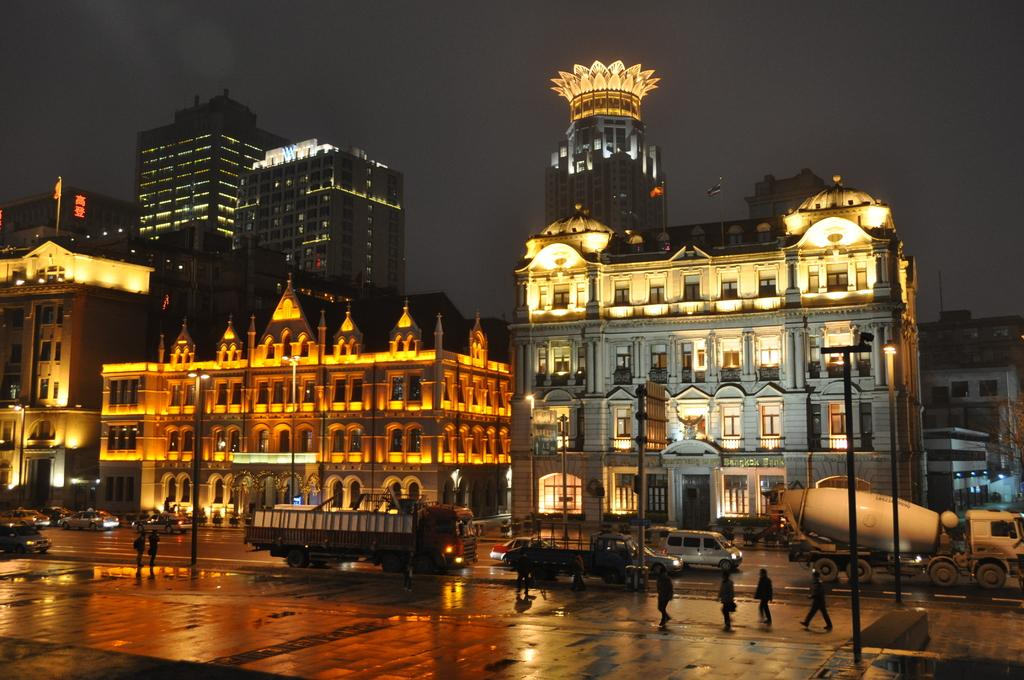What type of structures can be seen in the image? There are buildings in the image. What type of illumination is present in the image? Electric lights and street lights are present in the image. What type of vertical structures can be seen in the image? Street poles are visible in the image. What type of activity is happening in the image? There are persons walking on the road and motor vehicles on the road in the image. What type of decorative elements are present in the image? Flags are attached to flag posts in the image. What part of the natural environment is visible in the image? The sky is visible in the image. Can you tell me how many branches are on the cheese in the image? There is no cheese or branches present in the image. What type of gate is visible in the image? There is no gate present in the image. 